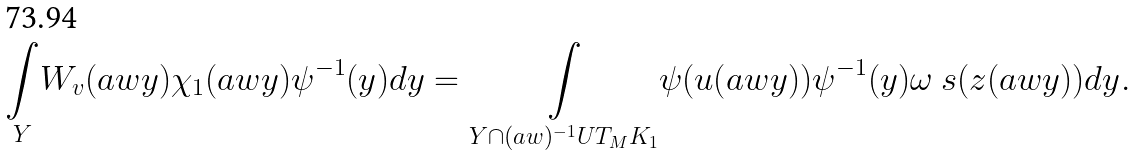Convert formula to latex. <formula><loc_0><loc_0><loc_500><loc_500>\underset { Y } { \int } W _ { v } ( a w y ) \chi _ { 1 } ( a w y ) \psi ^ { - 1 } ( y ) d y = \underset { Y \cap ( a w ) ^ { - 1 } U T _ { M } K _ { 1 } } { \int } \psi ( u ( a w y ) ) \psi ^ { - 1 } ( y ) \omega _ { \ } s ( z ( a w y ) ) d y .</formula> 